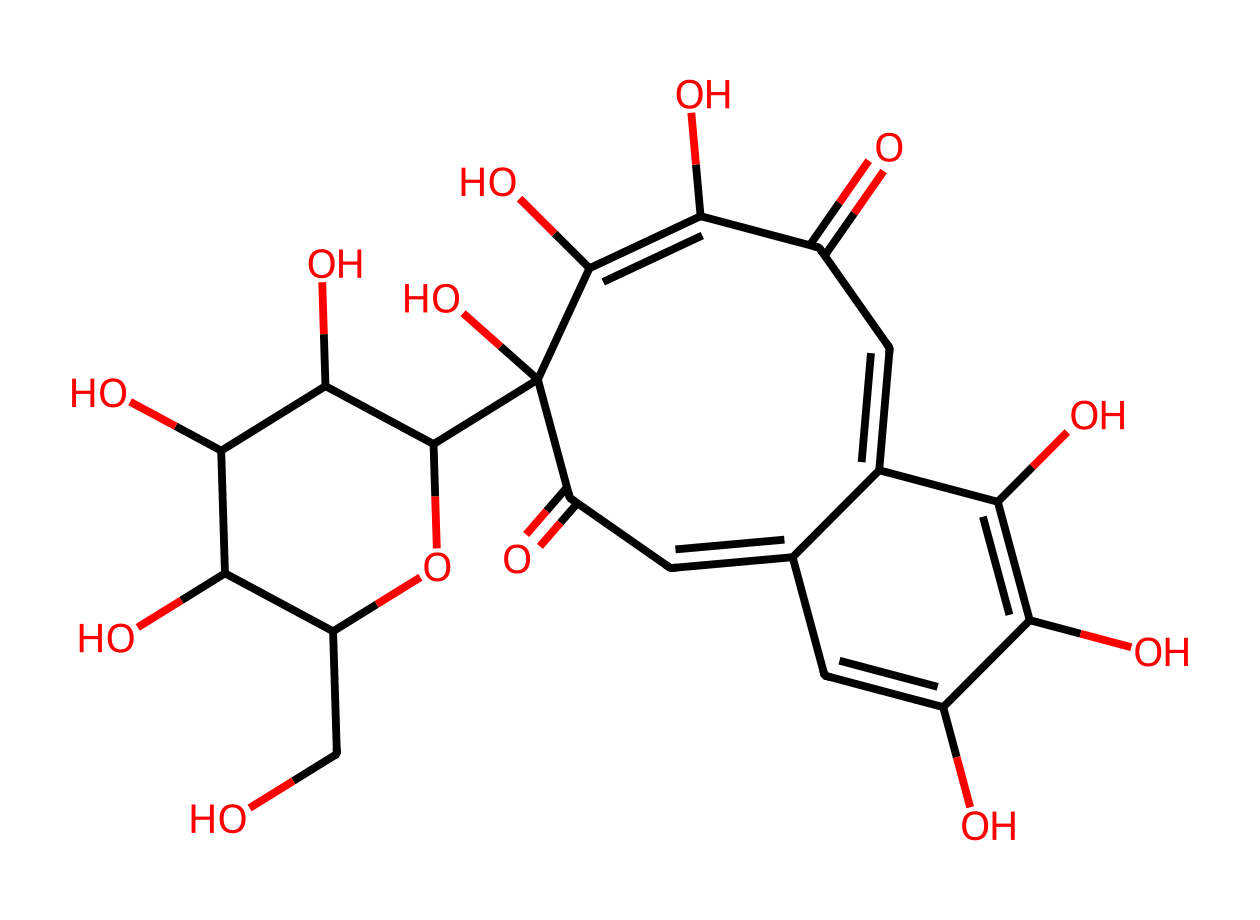What is the primary functional group present in this chemical structure? The chemical structure includes hydroxyl groups (-OH), which are characteristic functional groups in antioxidants. By locating the -OH groups in the structure, we can identify them as significant contributors to the molecule's properties as an antioxidant.
Answer: hydroxyl How many carbon atoms are present in this structure? By analyzing the SMILES representation, each carbon atom can be counted. Starting from the first carbon in the cyclic components and tracing through the structure, we find there are a total of 20 carbon atoms.
Answer: 20 What type of structure does this antioxidant compound exhibit? The compound has several rings connected by various functional groups. By deciphering the rings and identifying multiple interconnected carbon rings, it can be classified as a polycyclic structure.
Answer: polycyclic Does this compound contain any double bonds? Examining the SMILES representation, the presence of "=" indicates the existence of double bonds between certain carbon atoms. Counting these present indicators reveals there are 4 double bonds in the structure.
Answer: 4 What biological property is associated with the hydroxyl groups in this compound? Hydroxyl groups are known to be crucial contributors to the antioxidant properties of a compound. These groups can donate hydrogen atoms to free radicals, thereby stabilizing them and preventing oxidative damage in biological systems.
Answer: antioxidant 